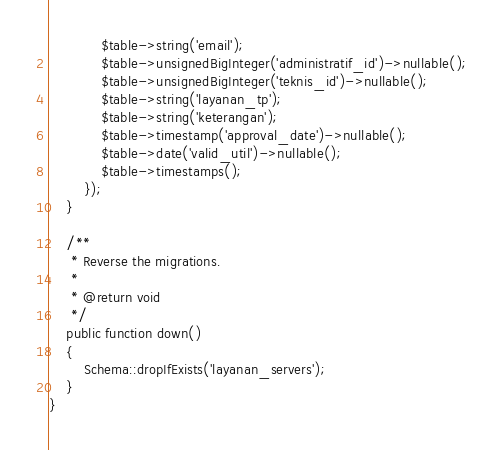<code> <loc_0><loc_0><loc_500><loc_500><_PHP_>            $table->string('email');
            $table->unsignedBigInteger('administratif_id')->nullable();
            $table->unsignedBigInteger('teknis_id')->nullable();
            $table->string('layanan_tp');
            $table->string('keterangan');
            $table->timestamp('approval_date')->nullable();
            $table->date('valid_util')->nullable();
            $table->timestamps();
        });
    }

    /**
     * Reverse the migrations.
     *
     * @return void
     */
    public function down()
    {
        Schema::dropIfExists('layanan_servers');
    }
}
</code> 